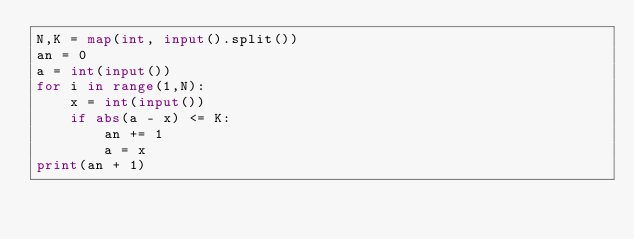<code> <loc_0><loc_0><loc_500><loc_500><_Python_>N,K = map(int, input().split())
an = 0
a = int(input())
for i in range(1,N):
    x = int(input())
    if abs(a - x) <= K:
        an += 1
        a = x
print(an + 1)</code> 